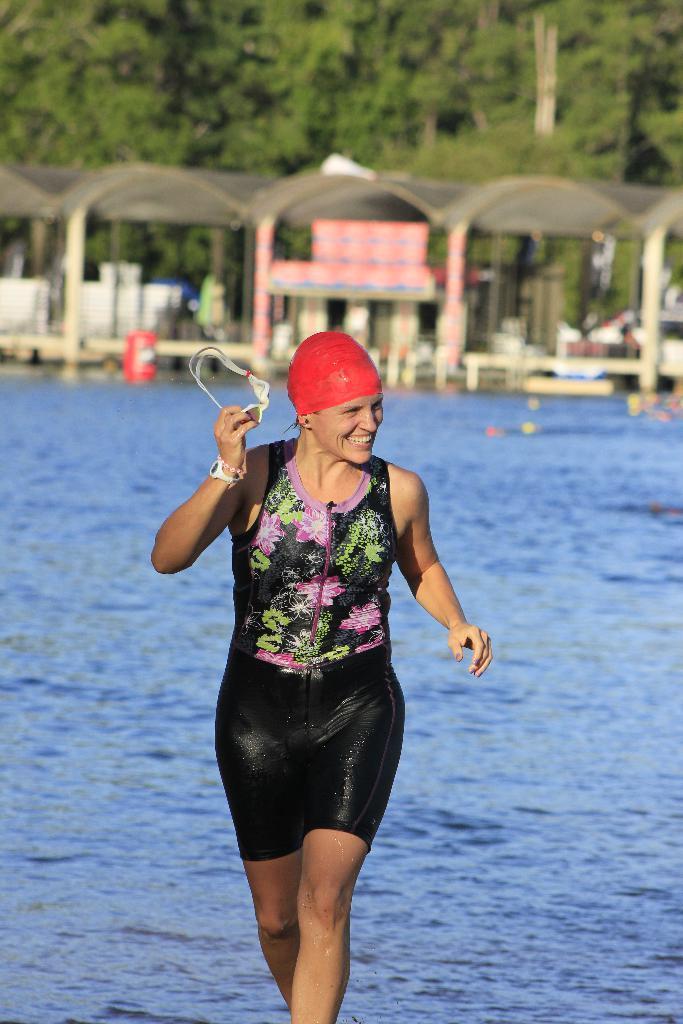Can you describe this image briefly? In this image we can see woman is wearing swimming dress with red cap and holding glasses in her hand. Behind her water, shelters and trees are there. 